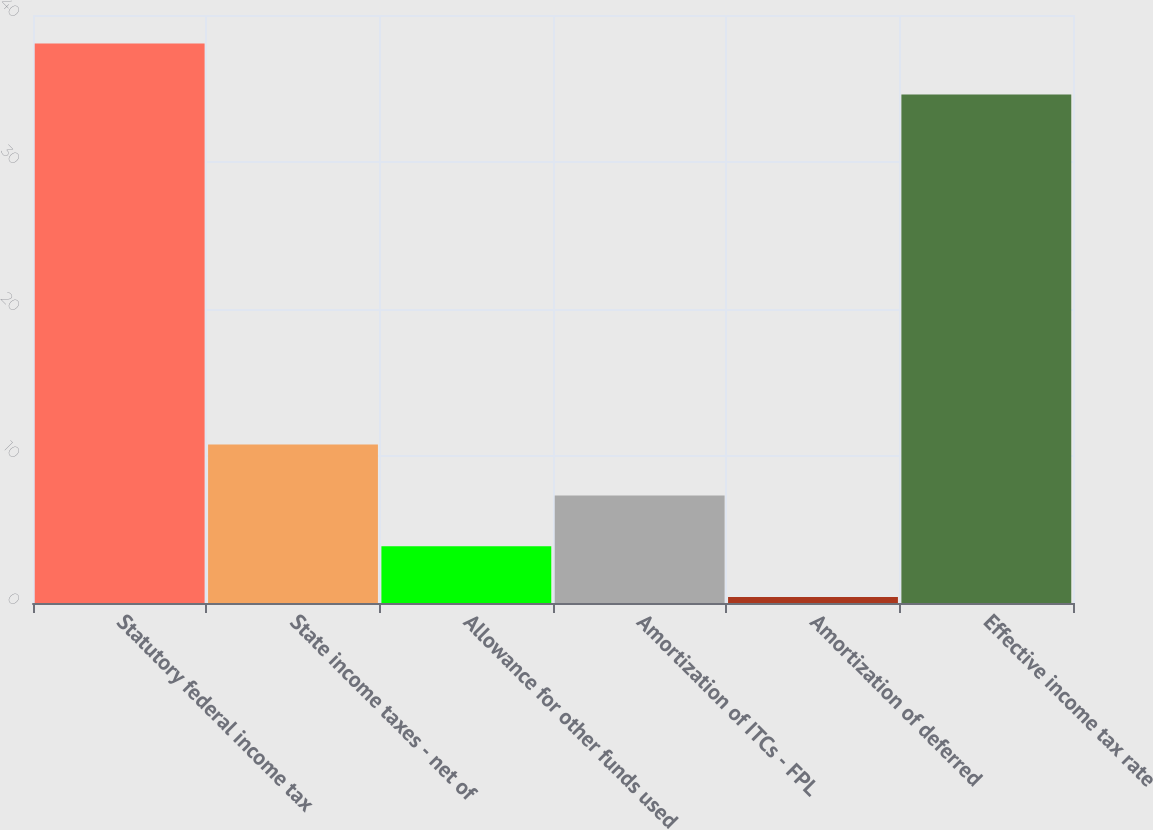Convert chart to OTSL. <chart><loc_0><loc_0><loc_500><loc_500><bar_chart><fcel>Statutory federal income tax<fcel>State income taxes - net of<fcel>Allowance for other funds used<fcel>Amortization of ITCs - FPL<fcel>Amortization of deferred<fcel>Effective income tax rate<nl><fcel>38.06<fcel>10.78<fcel>3.86<fcel>7.32<fcel>0.4<fcel>34.6<nl></chart> 